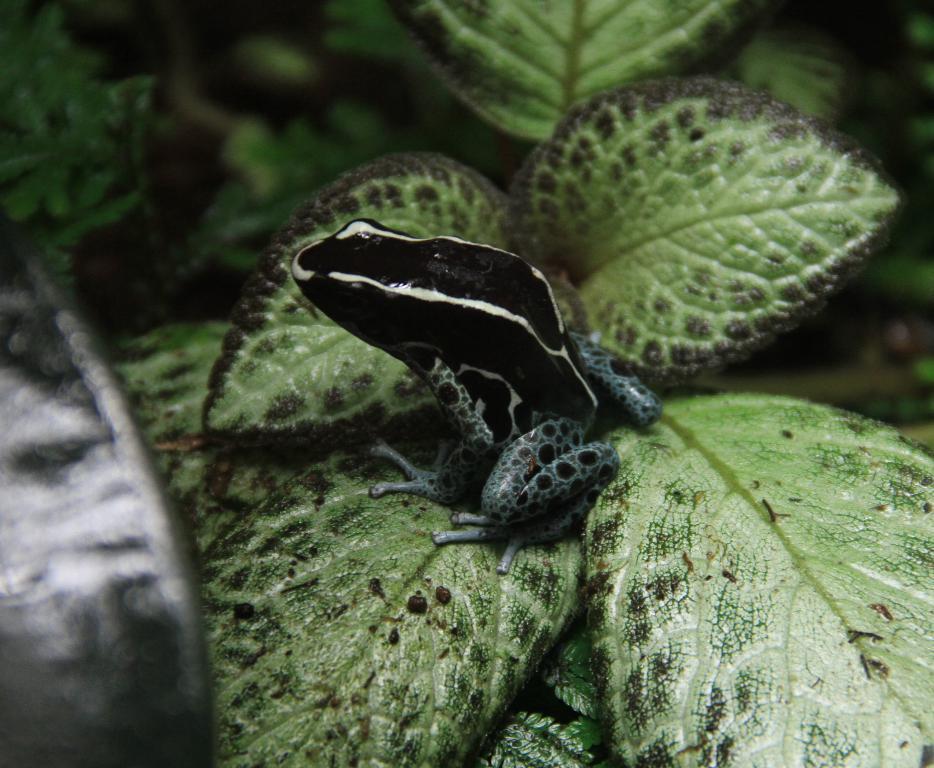Could you give a brief overview of what you see in this image? In the image there is a black frog sitting on a plant. 